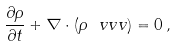Convert formula to latex. <formula><loc_0><loc_0><loc_500><loc_500>\frac { \partial \rho } { \partial t } + \nabla \cdot ( \rho \ v v { v } ) = 0 \, ,</formula> 